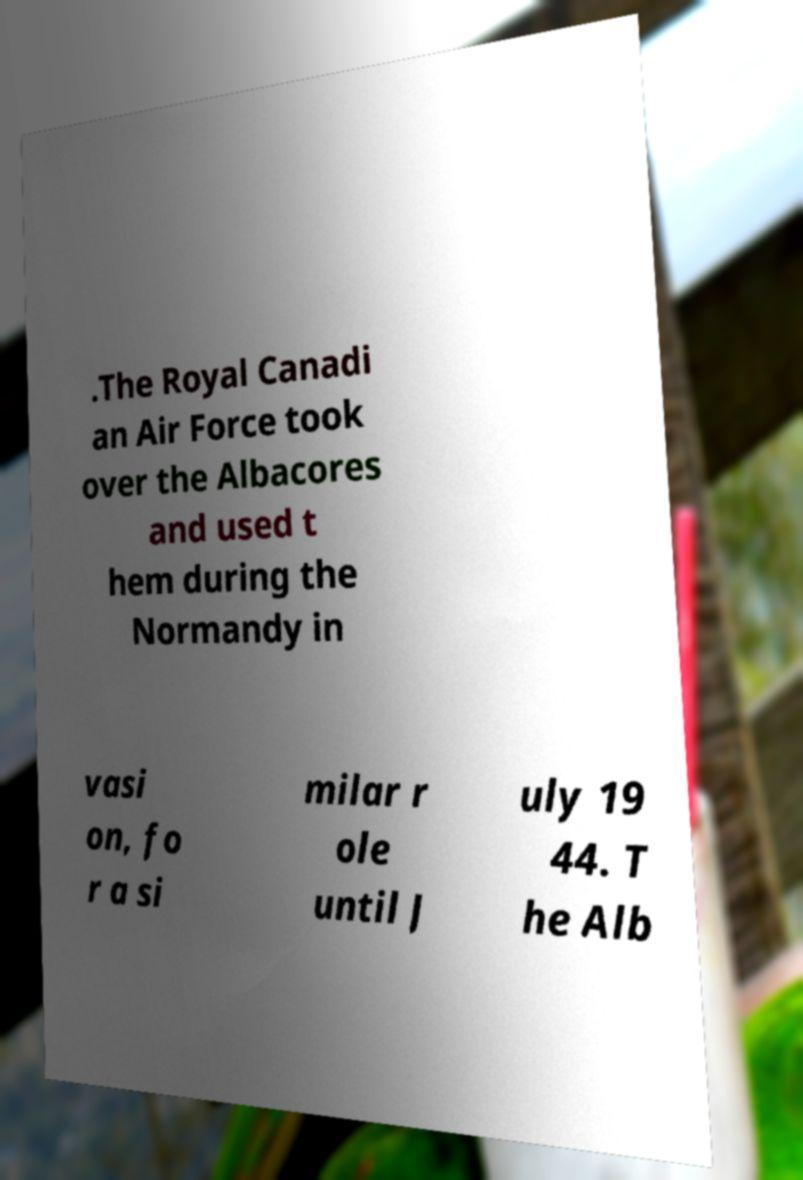For documentation purposes, I need the text within this image transcribed. Could you provide that? .The Royal Canadi an Air Force took over the Albacores and used t hem during the Normandy in vasi on, fo r a si milar r ole until J uly 19 44. T he Alb 